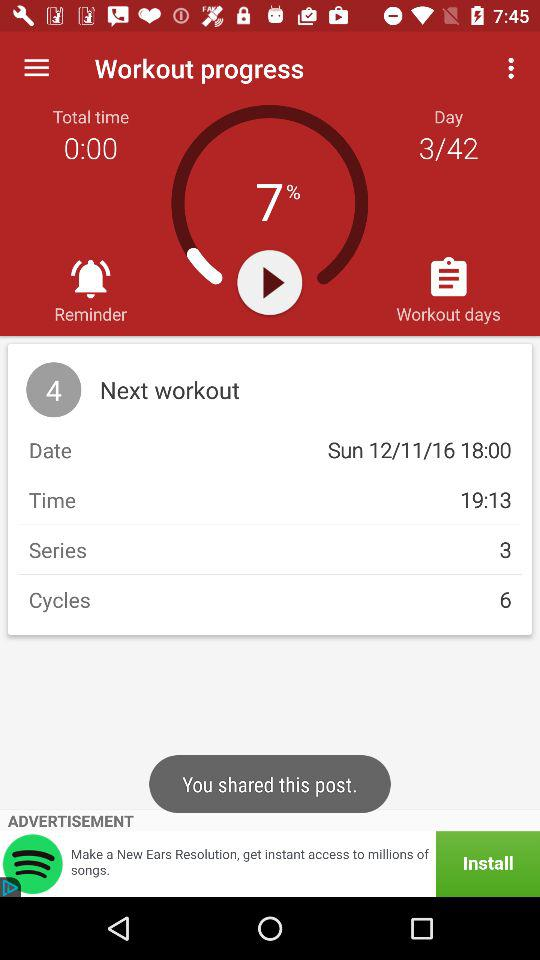How many cycles are in the next workout? There are 6 cycles in the next workout. 